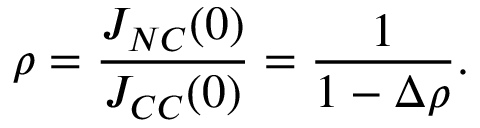<formula> <loc_0><loc_0><loc_500><loc_500>\rho = \frac { J _ { N C } ( 0 ) } { J _ { C C } ( 0 ) } = \frac { 1 } { 1 - \Delta \rho } .</formula> 